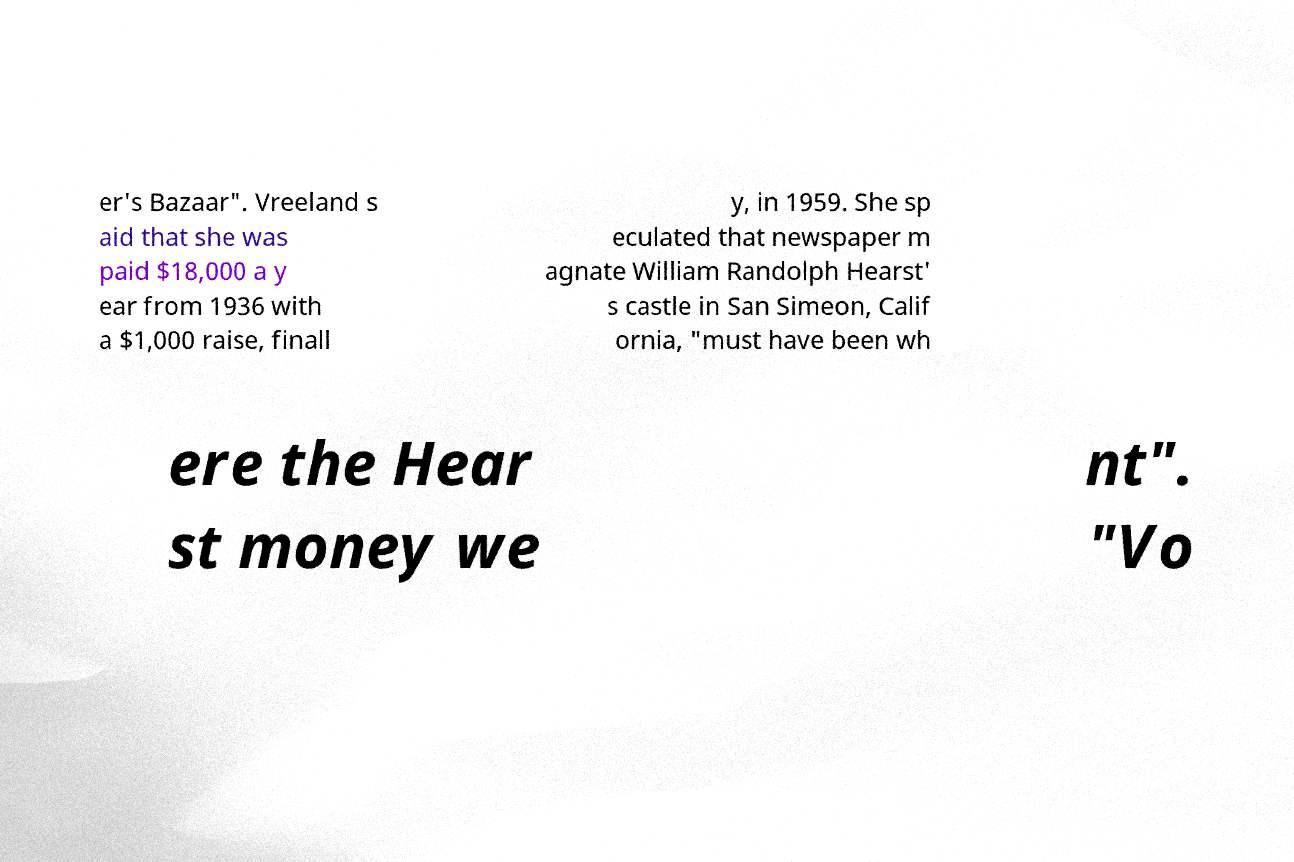For documentation purposes, I need the text within this image transcribed. Could you provide that? er's Bazaar". Vreeland s aid that she was paid $18,000 a y ear from 1936 with a $1,000 raise, finall y, in 1959. She sp eculated that newspaper m agnate William Randolph Hearst' s castle in San Simeon, Calif ornia, "must have been wh ere the Hear st money we nt". "Vo 